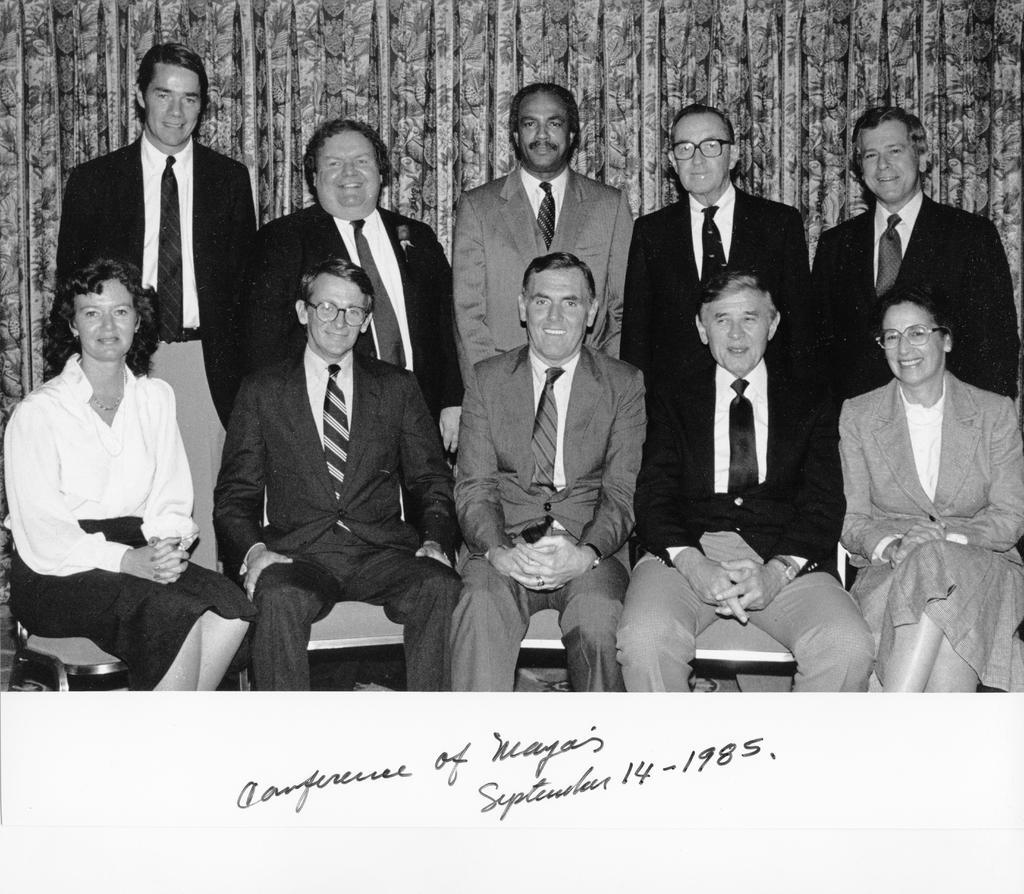What are the people in the image doing? There are people sitting on chairs and standing in the image. Can you describe the background of the image? There are curtains visible in the background of the image. What type of ice can be seen melting on the neck of the deer in the image? There is no ice or deer present in the image. 